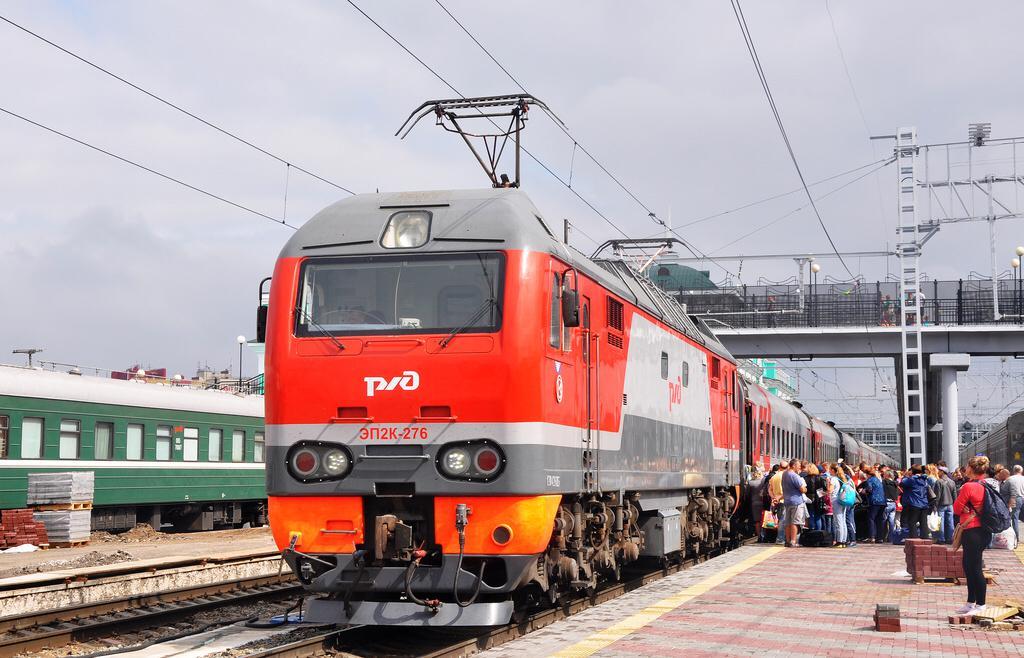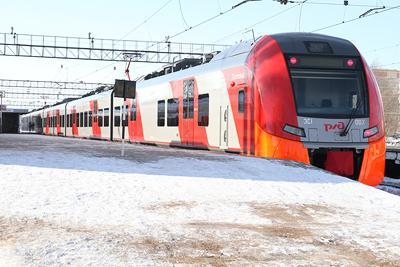The first image is the image on the left, the second image is the image on the right. Given the left and right images, does the statement "There is absolutely no visible grass in any of the images." hold true? Answer yes or no. Yes. The first image is the image on the left, the second image is the image on the right. Examine the images to the left and right. Is the description "People wait outside the station to board a red train." accurate? Answer yes or no. Yes. 